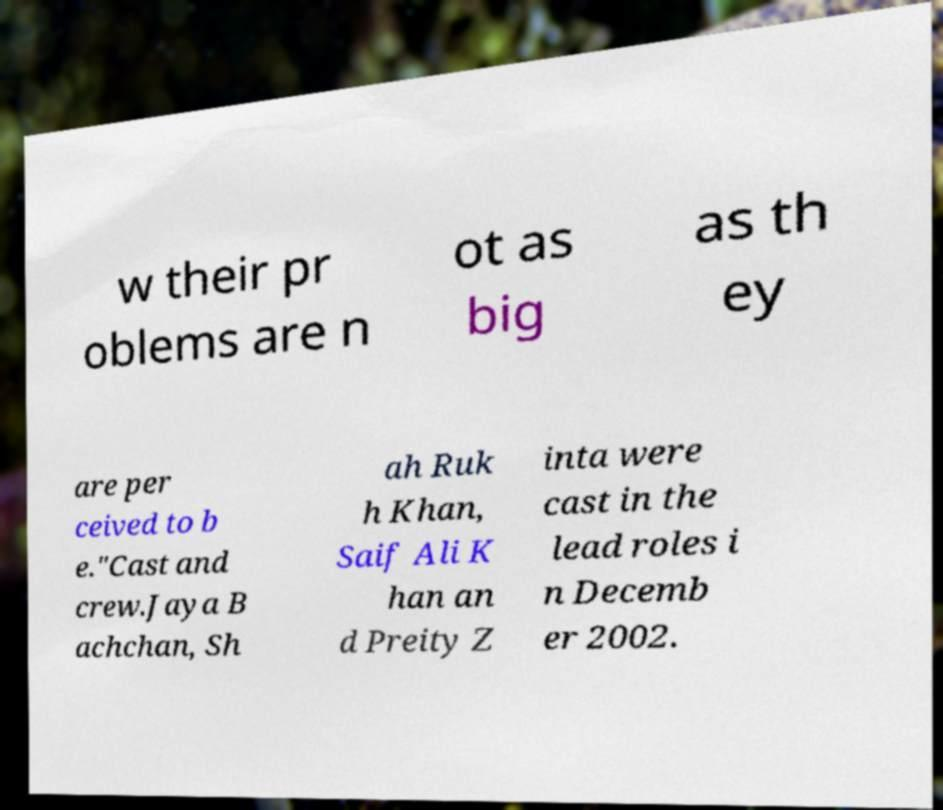Please identify and transcribe the text found in this image. w their pr oblems are n ot as big as th ey are per ceived to b e."Cast and crew.Jaya B achchan, Sh ah Ruk h Khan, Saif Ali K han an d Preity Z inta were cast in the lead roles i n Decemb er 2002. 